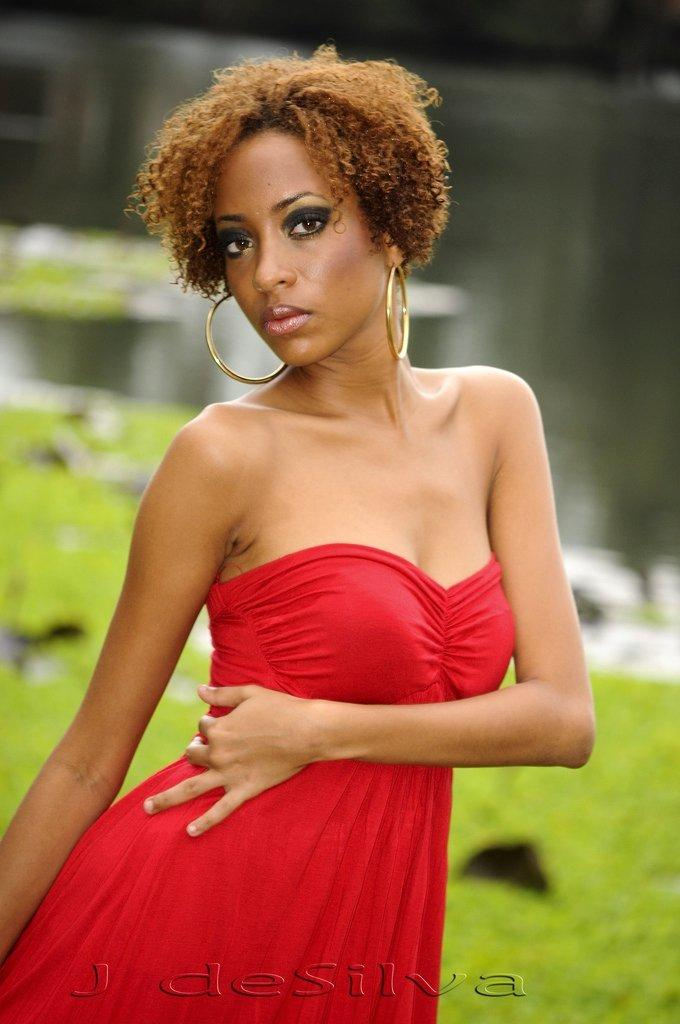Who is the main subject in the image? There is a lady in the image. What is the lady wearing in the image? The lady is wearing earrings and a red dress in the image. Can you describe the background of the image? The background of the image is blurred. Is there any additional information or markings on the image? Yes, there is a watermark at the bottom of the image. How does the lady's sense of humor manifest in the image? The image does not provide any information about the lady's sense of humor, so it cannot be determined from the image. 